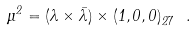Convert formula to latex. <formula><loc_0><loc_0><loc_500><loc_500>\mu ^ { 2 } = ( \lambda \times \bar { \lambda } ) \times ( 1 , 0 , 0 ) _ { \bar { 2 7 } } \ .</formula> 